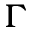<formula> <loc_0><loc_0><loc_500><loc_500>\Gamma</formula> 